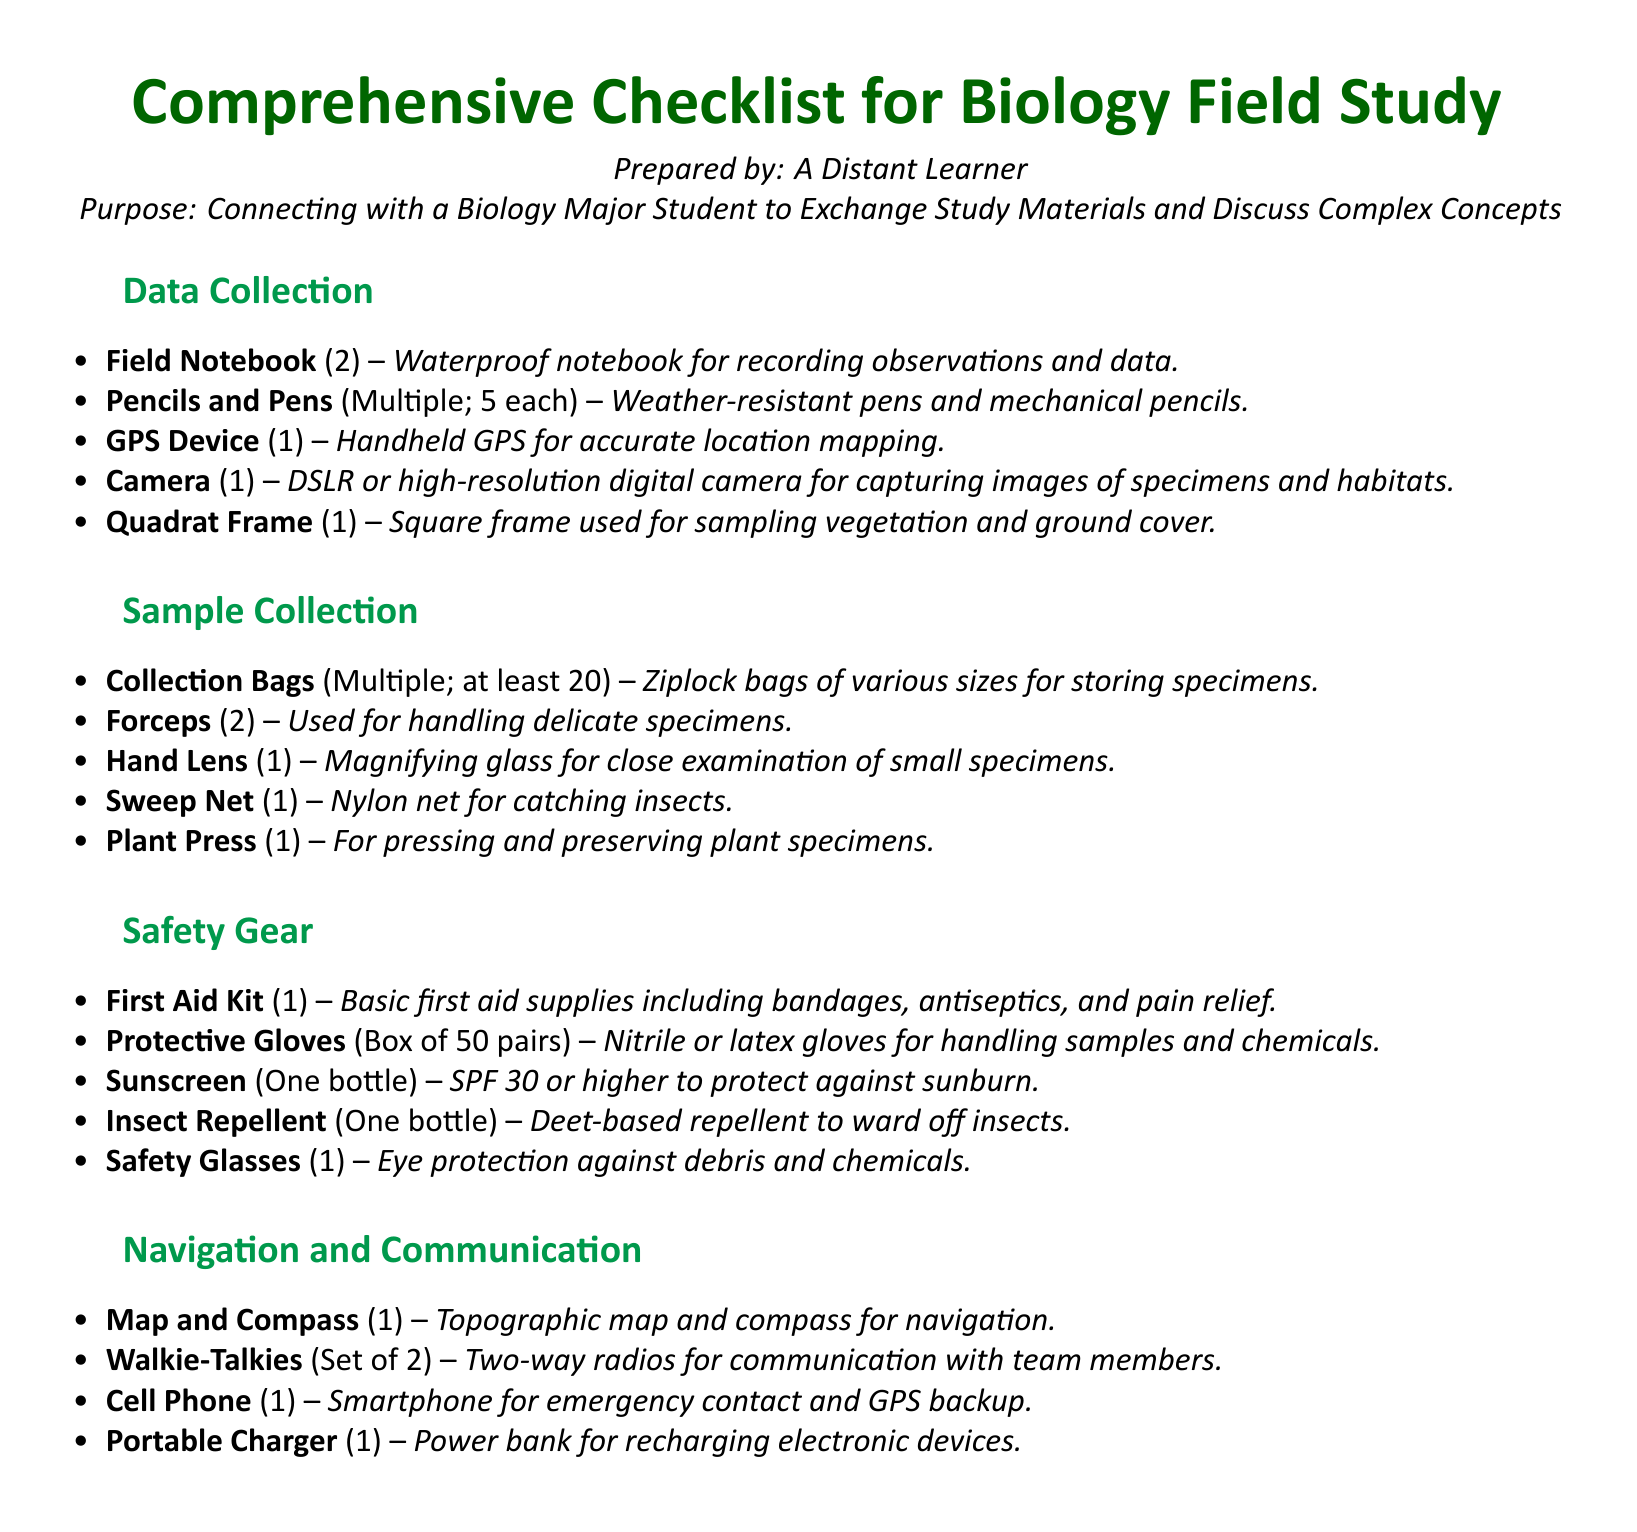What is the total number of Forceps required? The document specifies that 2 Forceps are required for the field study.
Answer: 2 How many Collection Bags should be packed? The packing list indicates that there should be at least 20 Collection Bags of various sizes.
Answer: At least 20 What type of gloves are required for safety? The document states that nitrile or latex gloves are required for handling samples and chemicals.
Answer: Nitrile or latex How many items are listed under Safety Gear? There are 5 items listed under the Safety Gear category.
Answer: 5 What is the purpose of the Quadrant Frame? The Quadrant Frame is used for sampling vegetation and ground cover in field studies.
Answer: Sampling vegetation and ground cover How many Walkie-Talkies are included in the list? The packing list includes a set of 2 Walkie-Talkies for communication with team members.
Answer: Set of 2 What is the SPF requirement for Sunscreen? The document specifies that the Sunscreen should be SPF 30 or higher.
Answer: SPF 30 or higher What is the total quantity of Pencils and Pens required? The document indicates that multiple pencils and pens are required, stating 5 each.
Answer: Multiple; 5 each 